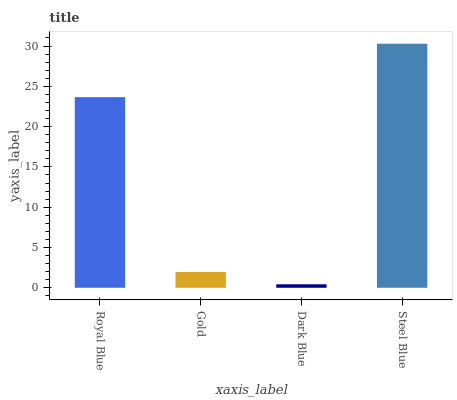Is Dark Blue the minimum?
Answer yes or no. Yes. Is Steel Blue the maximum?
Answer yes or no. Yes. Is Gold the minimum?
Answer yes or no. No. Is Gold the maximum?
Answer yes or no. No. Is Royal Blue greater than Gold?
Answer yes or no. Yes. Is Gold less than Royal Blue?
Answer yes or no. Yes. Is Gold greater than Royal Blue?
Answer yes or no. No. Is Royal Blue less than Gold?
Answer yes or no. No. Is Royal Blue the high median?
Answer yes or no. Yes. Is Gold the low median?
Answer yes or no. Yes. Is Gold the high median?
Answer yes or no. No. Is Steel Blue the low median?
Answer yes or no. No. 